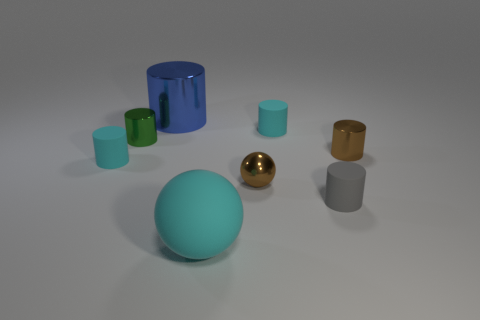Add 1 green metal cylinders. How many objects exist? 9 Subtract all purple spheres. How many cyan cylinders are left? 2 Subtract all brown metal cylinders. How many cylinders are left? 5 Add 4 big blue shiny things. How many big blue shiny things exist? 5 Subtract all brown spheres. How many spheres are left? 1 Subtract 0 gray cubes. How many objects are left? 8 Subtract all spheres. How many objects are left? 6 Subtract 1 cylinders. How many cylinders are left? 5 Subtract all yellow spheres. Subtract all purple cubes. How many spheres are left? 2 Subtract all tiny brown metallic blocks. Subtract all tiny gray matte cylinders. How many objects are left? 7 